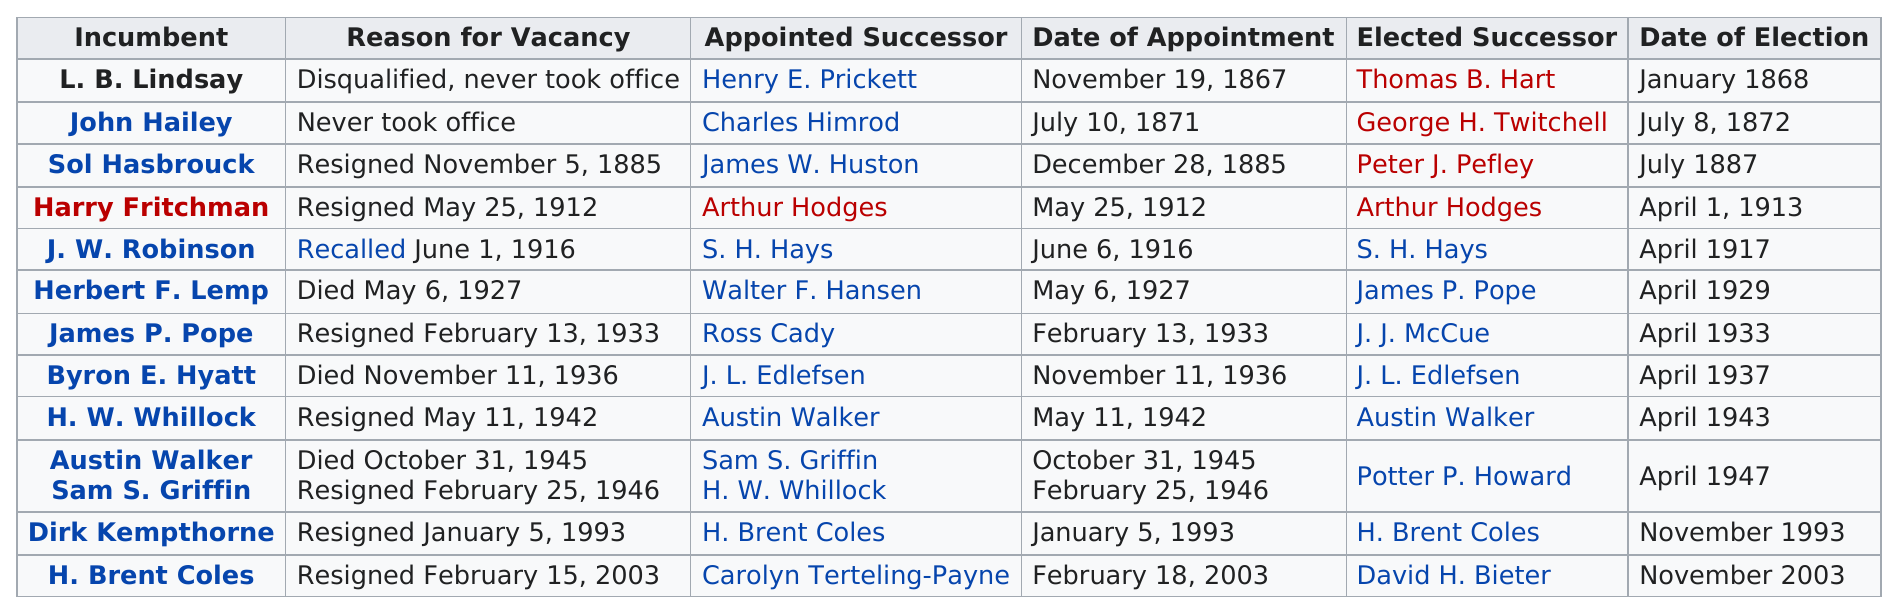List a handful of essential elements in this visual. There have been 12 mayors of Boise, Idaho. James P. Pope resigned earlier than H.W. Whillock. In 1933, if any, James P. Pope and possibly other mayors resigned from their mayoralty. Dirk Kempthorne was succeeded by H. Brent Coles, who was appointed after him. J.W. Robinson was the only incumbent appointed in the month of June. 